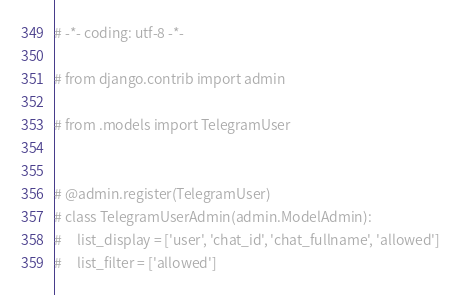<code> <loc_0><loc_0><loc_500><loc_500><_Python_># -*- coding: utf-8 -*-

# from django.contrib import admin

# from .models import TelegramUser


# @admin.register(TelegramUser)
# class TelegramUserAdmin(admin.ModelAdmin):
#     list_display = ['user', 'chat_id', 'chat_fullname', 'allowed']
#     list_filter = ['allowed']
</code> 